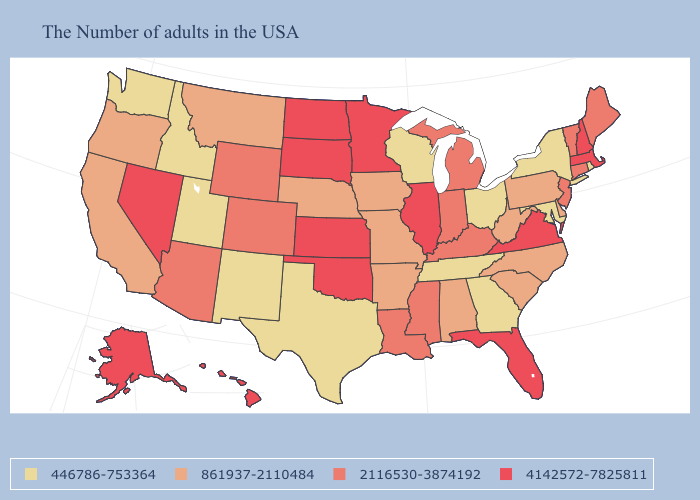What is the highest value in states that border Texas?
Keep it brief. 4142572-7825811. What is the value of Oklahoma?
Give a very brief answer. 4142572-7825811. Name the states that have a value in the range 2116530-3874192?
Be succinct. Maine, Vermont, Connecticut, New Jersey, Michigan, Kentucky, Indiana, Mississippi, Louisiana, Wyoming, Colorado, Arizona. What is the value of West Virginia?
Quick response, please. 861937-2110484. Name the states that have a value in the range 446786-753364?
Give a very brief answer. Rhode Island, New York, Maryland, Ohio, Georgia, Tennessee, Wisconsin, Texas, New Mexico, Utah, Idaho, Washington. What is the value of Michigan?
Short answer required. 2116530-3874192. Does New Hampshire have the highest value in the Northeast?
Write a very short answer. Yes. Does the map have missing data?
Quick response, please. No. How many symbols are there in the legend?
Keep it brief. 4. Among the states that border Ohio , does Pennsylvania have the highest value?
Write a very short answer. No. Name the states that have a value in the range 861937-2110484?
Short answer required. Delaware, Pennsylvania, North Carolina, South Carolina, West Virginia, Alabama, Missouri, Arkansas, Iowa, Nebraska, Montana, California, Oregon. Does Indiana have a lower value than Massachusetts?
Quick response, please. Yes. Does Florida have the same value as Illinois?
Write a very short answer. Yes. Does Utah have a lower value than California?
Short answer required. Yes. What is the value of West Virginia?
Short answer required. 861937-2110484. 